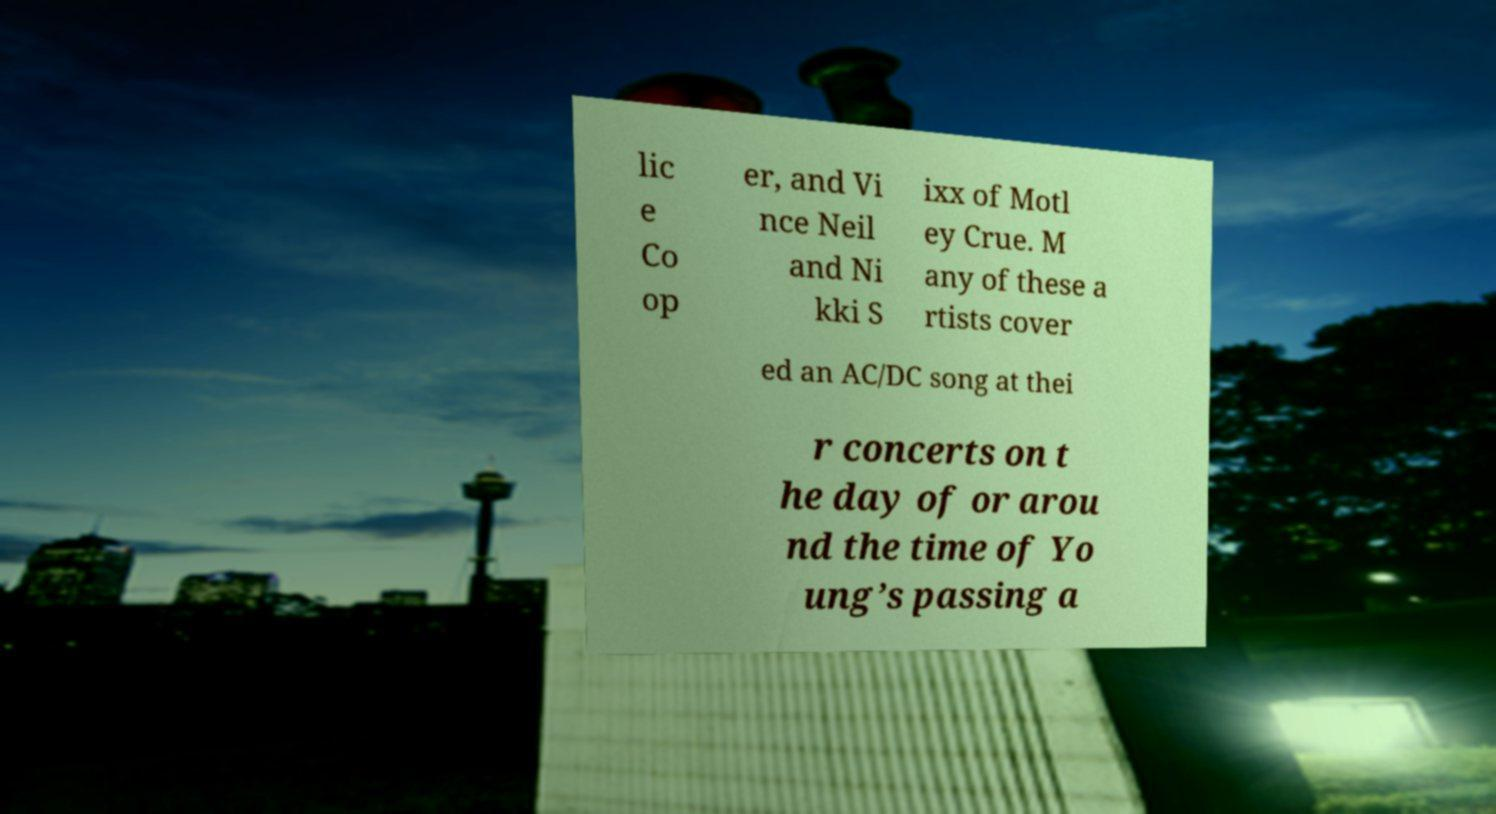I need the written content from this picture converted into text. Can you do that? lic e Co op er, and Vi nce Neil and Ni kki S ixx of Motl ey Crue. M any of these a rtists cover ed an AC/DC song at thei r concerts on t he day of or arou nd the time of Yo ung’s passing a 